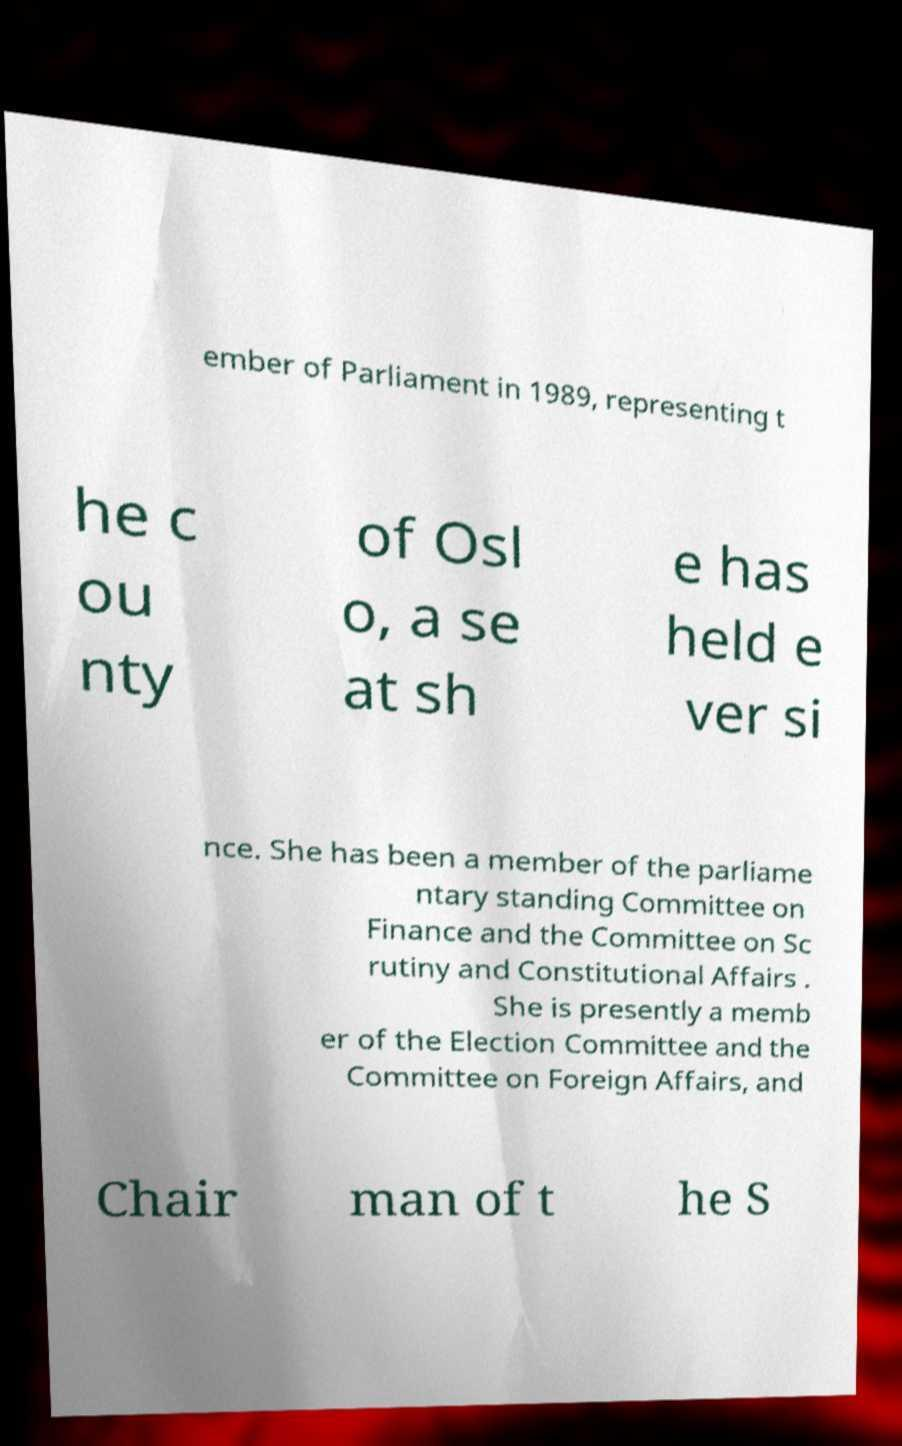There's text embedded in this image that I need extracted. Can you transcribe it verbatim? ember of Parliament in 1989, representing t he c ou nty of Osl o, a se at sh e has held e ver si nce. She has been a member of the parliame ntary standing Committee on Finance and the Committee on Sc rutiny and Constitutional Affairs . She is presently a memb er of the Election Committee and the Committee on Foreign Affairs, and Chair man of t he S 